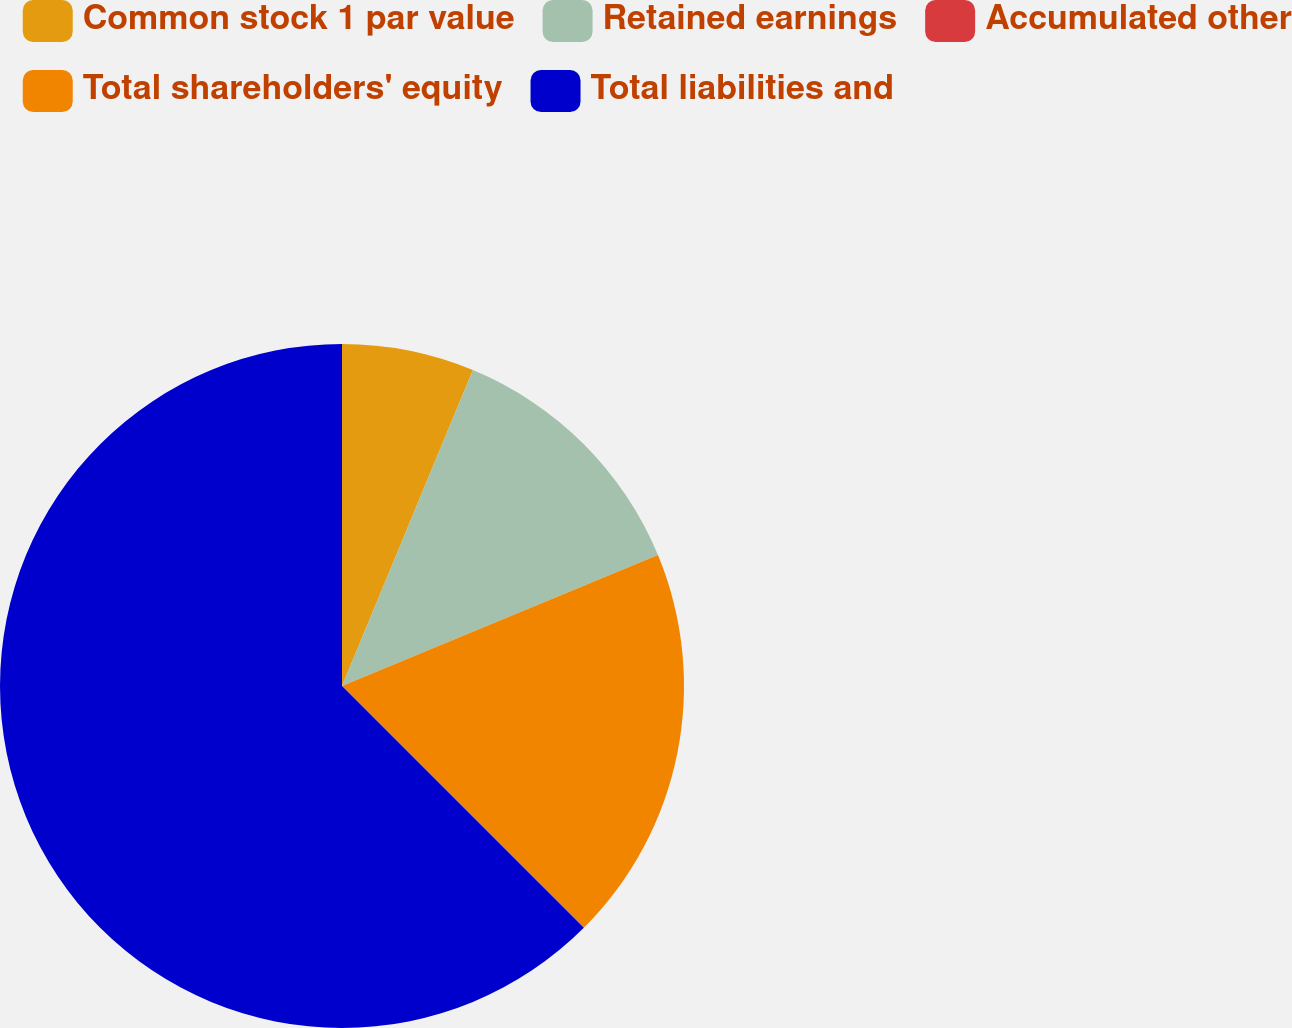Convert chart. <chart><loc_0><loc_0><loc_500><loc_500><pie_chart><fcel>Common stock 1 par value<fcel>Retained earnings<fcel>Accumulated other<fcel>Total shareholders' equity<fcel>Total liabilities and<nl><fcel>6.25%<fcel>12.5%<fcel>0.0%<fcel>18.75%<fcel>62.5%<nl></chart> 